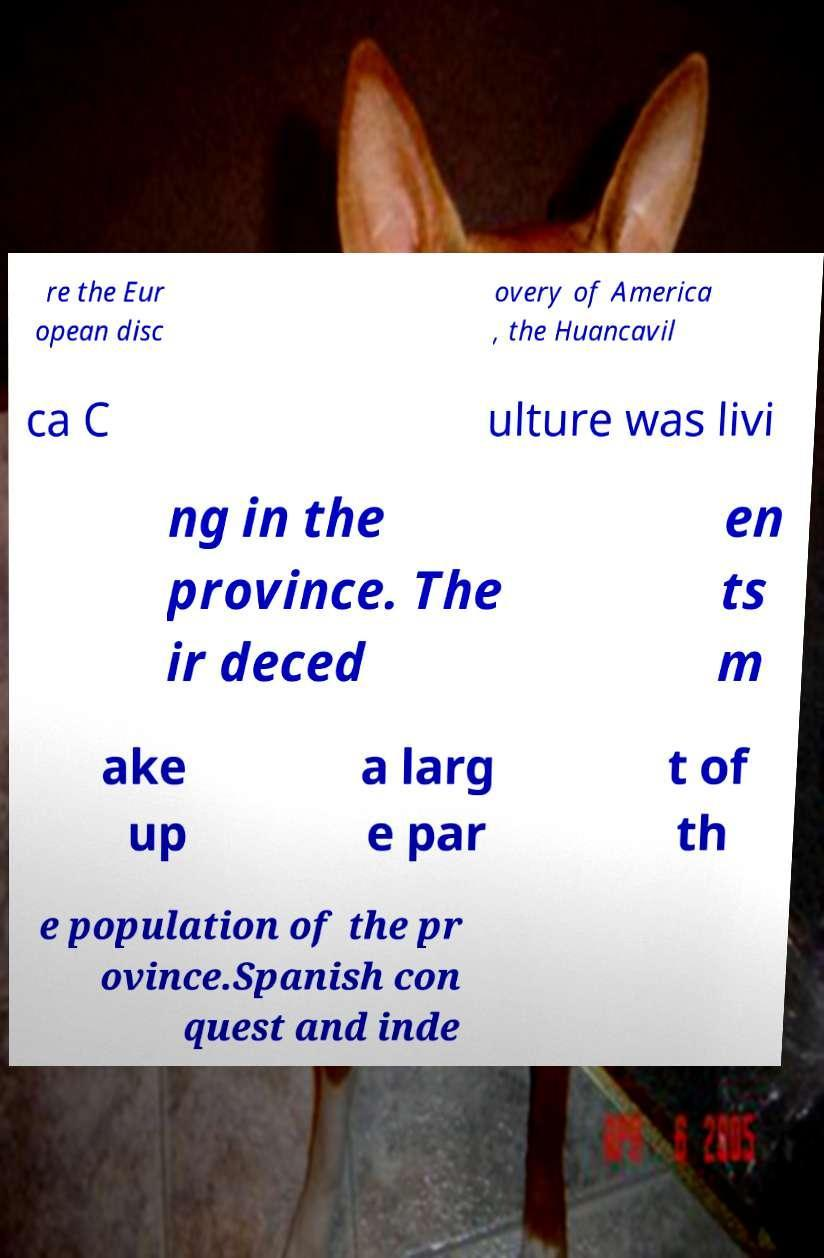Please identify and transcribe the text found in this image. re the Eur opean disc overy of America , the Huancavil ca C ulture was livi ng in the province. The ir deced en ts m ake up a larg e par t of th e population of the pr ovince.Spanish con quest and inde 